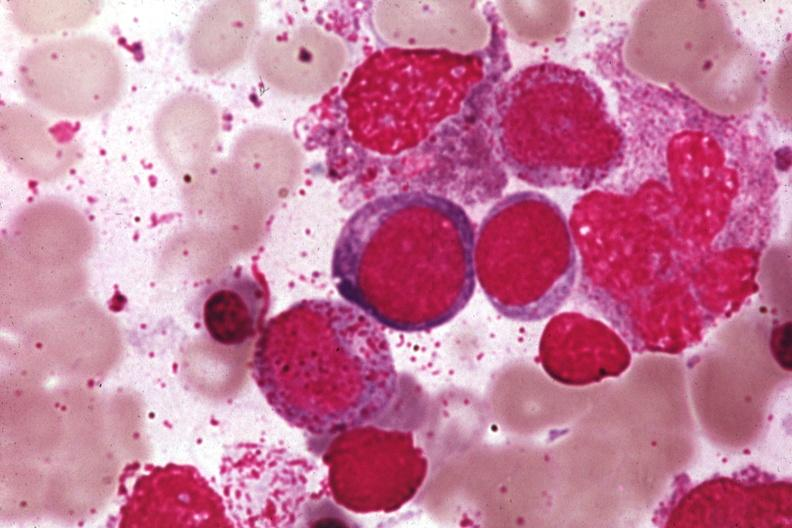what does this image show?
Answer the question using a single word or phrase. Wrights 